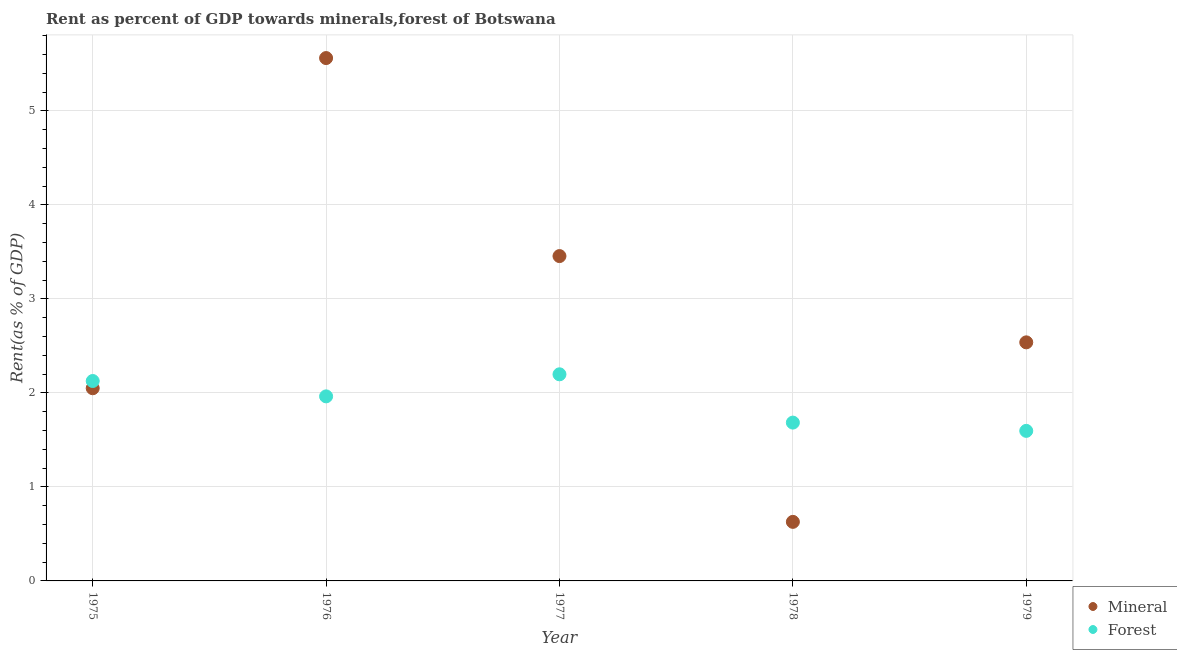Is the number of dotlines equal to the number of legend labels?
Offer a terse response. Yes. What is the forest rent in 1976?
Your answer should be compact. 1.96. Across all years, what is the maximum forest rent?
Your response must be concise. 2.2. Across all years, what is the minimum forest rent?
Ensure brevity in your answer.  1.6. In which year was the mineral rent maximum?
Your answer should be very brief. 1976. In which year was the mineral rent minimum?
Offer a very short reply. 1978. What is the total mineral rent in the graph?
Your response must be concise. 14.24. What is the difference between the forest rent in 1975 and that in 1976?
Ensure brevity in your answer.  0.16. What is the difference between the mineral rent in 1975 and the forest rent in 1976?
Your response must be concise. 0.09. What is the average forest rent per year?
Offer a terse response. 1.91. In the year 1975, what is the difference between the forest rent and mineral rent?
Your answer should be very brief. 0.08. In how many years, is the forest rent greater than 3.6 %?
Make the answer very short. 0. What is the ratio of the mineral rent in 1976 to that in 1978?
Give a very brief answer. 8.85. Is the mineral rent in 1976 less than that in 1978?
Your answer should be very brief. No. Is the difference between the forest rent in 1975 and 1976 greater than the difference between the mineral rent in 1975 and 1976?
Your answer should be very brief. Yes. What is the difference between the highest and the second highest forest rent?
Offer a very short reply. 0.07. What is the difference between the highest and the lowest mineral rent?
Make the answer very short. 4.93. In how many years, is the mineral rent greater than the average mineral rent taken over all years?
Your answer should be very brief. 2. Is the forest rent strictly greater than the mineral rent over the years?
Offer a terse response. No. Is the forest rent strictly less than the mineral rent over the years?
Your answer should be very brief. No. What is the difference between two consecutive major ticks on the Y-axis?
Offer a very short reply. 1. How many legend labels are there?
Give a very brief answer. 2. What is the title of the graph?
Provide a short and direct response. Rent as percent of GDP towards minerals,forest of Botswana. What is the label or title of the Y-axis?
Ensure brevity in your answer.  Rent(as % of GDP). What is the Rent(as % of GDP) in Mineral in 1975?
Make the answer very short. 2.05. What is the Rent(as % of GDP) of Forest in 1975?
Ensure brevity in your answer.  2.13. What is the Rent(as % of GDP) of Mineral in 1976?
Provide a succinct answer. 5.56. What is the Rent(as % of GDP) of Forest in 1976?
Your answer should be very brief. 1.96. What is the Rent(as % of GDP) in Mineral in 1977?
Your response must be concise. 3.46. What is the Rent(as % of GDP) of Forest in 1977?
Provide a succinct answer. 2.2. What is the Rent(as % of GDP) in Mineral in 1978?
Provide a short and direct response. 0.63. What is the Rent(as % of GDP) of Forest in 1978?
Offer a very short reply. 1.68. What is the Rent(as % of GDP) in Mineral in 1979?
Give a very brief answer. 2.54. What is the Rent(as % of GDP) in Forest in 1979?
Provide a succinct answer. 1.6. Across all years, what is the maximum Rent(as % of GDP) of Mineral?
Offer a very short reply. 5.56. Across all years, what is the maximum Rent(as % of GDP) in Forest?
Your answer should be compact. 2.2. Across all years, what is the minimum Rent(as % of GDP) in Mineral?
Make the answer very short. 0.63. Across all years, what is the minimum Rent(as % of GDP) in Forest?
Provide a short and direct response. 1.6. What is the total Rent(as % of GDP) of Mineral in the graph?
Provide a succinct answer. 14.24. What is the total Rent(as % of GDP) of Forest in the graph?
Provide a short and direct response. 9.57. What is the difference between the Rent(as % of GDP) in Mineral in 1975 and that in 1976?
Your response must be concise. -3.51. What is the difference between the Rent(as % of GDP) of Forest in 1975 and that in 1976?
Give a very brief answer. 0.16. What is the difference between the Rent(as % of GDP) of Mineral in 1975 and that in 1977?
Keep it short and to the point. -1.41. What is the difference between the Rent(as % of GDP) of Forest in 1975 and that in 1977?
Make the answer very short. -0.07. What is the difference between the Rent(as % of GDP) in Mineral in 1975 and that in 1978?
Ensure brevity in your answer.  1.42. What is the difference between the Rent(as % of GDP) in Forest in 1975 and that in 1978?
Make the answer very short. 0.44. What is the difference between the Rent(as % of GDP) of Mineral in 1975 and that in 1979?
Offer a very short reply. -0.49. What is the difference between the Rent(as % of GDP) in Forest in 1975 and that in 1979?
Provide a short and direct response. 0.53. What is the difference between the Rent(as % of GDP) in Mineral in 1976 and that in 1977?
Offer a very short reply. 2.11. What is the difference between the Rent(as % of GDP) of Forest in 1976 and that in 1977?
Your answer should be very brief. -0.23. What is the difference between the Rent(as % of GDP) in Mineral in 1976 and that in 1978?
Ensure brevity in your answer.  4.93. What is the difference between the Rent(as % of GDP) in Forest in 1976 and that in 1978?
Your response must be concise. 0.28. What is the difference between the Rent(as % of GDP) of Mineral in 1976 and that in 1979?
Ensure brevity in your answer.  3.02. What is the difference between the Rent(as % of GDP) of Forest in 1976 and that in 1979?
Your answer should be compact. 0.37. What is the difference between the Rent(as % of GDP) of Mineral in 1977 and that in 1978?
Your response must be concise. 2.83. What is the difference between the Rent(as % of GDP) of Forest in 1977 and that in 1978?
Offer a terse response. 0.51. What is the difference between the Rent(as % of GDP) in Mineral in 1977 and that in 1979?
Provide a short and direct response. 0.92. What is the difference between the Rent(as % of GDP) of Forest in 1977 and that in 1979?
Keep it short and to the point. 0.6. What is the difference between the Rent(as % of GDP) in Mineral in 1978 and that in 1979?
Offer a terse response. -1.91. What is the difference between the Rent(as % of GDP) in Forest in 1978 and that in 1979?
Provide a short and direct response. 0.09. What is the difference between the Rent(as % of GDP) in Mineral in 1975 and the Rent(as % of GDP) in Forest in 1976?
Your answer should be very brief. 0.09. What is the difference between the Rent(as % of GDP) of Mineral in 1975 and the Rent(as % of GDP) of Forest in 1977?
Keep it short and to the point. -0.15. What is the difference between the Rent(as % of GDP) in Mineral in 1975 and the Rent(as % of GDP) in Forest in 1978?
Give a very brief answer. 0.37. What is the difference between the Rent(as % of GDP) in Mineral in 1975 and the Rent(as % of GDP) in Forest in 1979?
Give a very brief answer. 0.45. What is the difference between the Rent(as % of GDP) in Mineral in 1976 and the Rent(as % of GDP) in Forest in 1977?
Offer a very short reply. 3.36. What is the difference between the Rent(as % of GDP) of Mineral in 1976 and the Rent(as % of GDP) of Forest in 1978?
Your answer should be very brief. 3.88. What is the difference between the Rent(as % of GDP) of Mineral in 1976 and the Rent(as % of GDP) of Forest in 1979?
Offer a terse response. 3.97. What is the difference between the Rent(as % of GDP) of Mineral in 1977 and the Rent(as % of GDP) of Forest in 1978?
Make the answer very short. 1.77. What is the difference between the Rent(as % of GDP) in Mineral in 1977 and the Rent(as % of GDP) in Forest in 1979?
Your answer should be compact. 1.86. What is the difference between the Rent(as % of GDP) in Mineral in 1978 and the Rent(as % of GDP) in Forest in 1979?
Ensure brevity in your answer.  -0.97. What is the average Rent(as % of GDP) in Mineral per year?
Make the answer very short. 2.85. What is the average Rent(as % of GDP) of Forest per year?
Provide a short and direct response. 1.91. In the year 1975, what is the difference between the Rent(as % of GDP) in Mineral and Rent(as % of GDP) in Forest?
Your answer should be compact. -0.08. In the year 1976, what is the difference between the Rent(as % of GDP) in Mineral and Rent(as % of GDP) in Forest?
Provide a short and direct response. 3.6. In the year 1977, what is the difference between the Rent(as % of GDP) of Mineral and Rent(as % of GDP) of Forest?
Provide a short and direct response. 1.26. In the year 1978, what is the difference between the Rent(as % of GDP) in Mineral and Rent(as % of GDP) in Forest?
Offer a terse response. -1.06. In the year 1979, what is the difference between the Rent(as % of GDP) in Mineral and Rent(as % of GDP) in Forest?
Give a very brief answer. 0.94. What is the ratio of the Rent(as % of GDP) in Mineral in 1975 to that in 1976?
Your response must be concise. 0.37. What is the ratio of the Rent(as % of GDP) in Forest in 1975 to that in 1976?
Your answer should be very brief. 1.08. What is the ratio of the Rent(as % of GDP) in Mineral in 1975 to that in 1977?
Ensure brevity in your answer.  0.59. What is the ratio of the Rent(as % of GDP) of Forest in 1975 to that in 1977?
Your answer should be compact. 0.97. What is the ratio of the Rent(as % of GDP) of Mineral in 1975 to that in 1978?
Provide a short and direct response. 3.26. What is the ratio of the Rent(as % of GDP) of Forest in 1975 to that in 1978?
Keep it short and to the point. 1.26. What is the ratio of the Rent(as % of GDP) in Mineral in 1975 to that in 1979?
Provide a succinct answer. 0.81. What is the ratio of the Rent(as % of GDP) of Forest in 1975 to that in 1979?
Provide a succinct answer. 1.33. What is the ratio of the Rent(as % of GDP) of Mineral in 1976 to that in 1977?
Your answer should be very brief. 1.61. What is the ratio of the Rent(as % of GDP) in Forest in 1976 to that in 1977?
Keep it short and to the point. 0.89. What is the ratio of the Rent(as % of GDP) in Mineral in 1976 to that in 1978?
Give a very brief answer. 8.85. What is the ratio of the Rent(as % of GDP) in Forest in 1976 to that in 1978?
Give a very brief answer. 1.17. What is the ratio of the Rent(as % of GDP) of Mineral in 1976 to that in 1979?
Give a very brief answer. 2.19. What is the ratio of the Rent(as % of GDP) of Forest in 1976 to that in 1979?
Provide a succinct answer. 1.23. What is the ratio of the Rent(as % of GDP) in Mineral in 1977 to that in 1978?
Your answer should be very brief. 5.5. What is the ratio of the Rent(as % of GDP) in Forest in 1977 to that in 1978?
Your response must be concise. 1.3. What is the ratio of the Rent(as % of GDP) in Mineral in 1977 to that in 1979?
Keep it short and to the point. 1.36. What is the ratio of the Rent(as % of GDP) in Forest in 1977 to that in 1979?
Give a very brief answer. 1.38. What is the ratio of the Rent(as % of GDP) in Mineral in 1978 to that in 1979?
Give a very brief answer. 0.25. What is the ratio of the Rent(as % of GDP) of Forest in 1978 to that in 1979?
Give a very brief answer. 1.06. What is the difference between the highest and the second highest Rent(as % of GDP) in Mineral?
Your answer should be very brief. 2.11. What is the difference between the highest and the second highest Rent(as % of GDP) of Forest?
Keep it short and to the point. 0.07. What is the difference between the highest and the lowest Rent(as % of GDP) of Mineral?
Give a very brief answer. 4.93. What is the difference between the highest and the lowest Rent(as % of GDP) of Forest?
Offer a terse response. 0.6. 